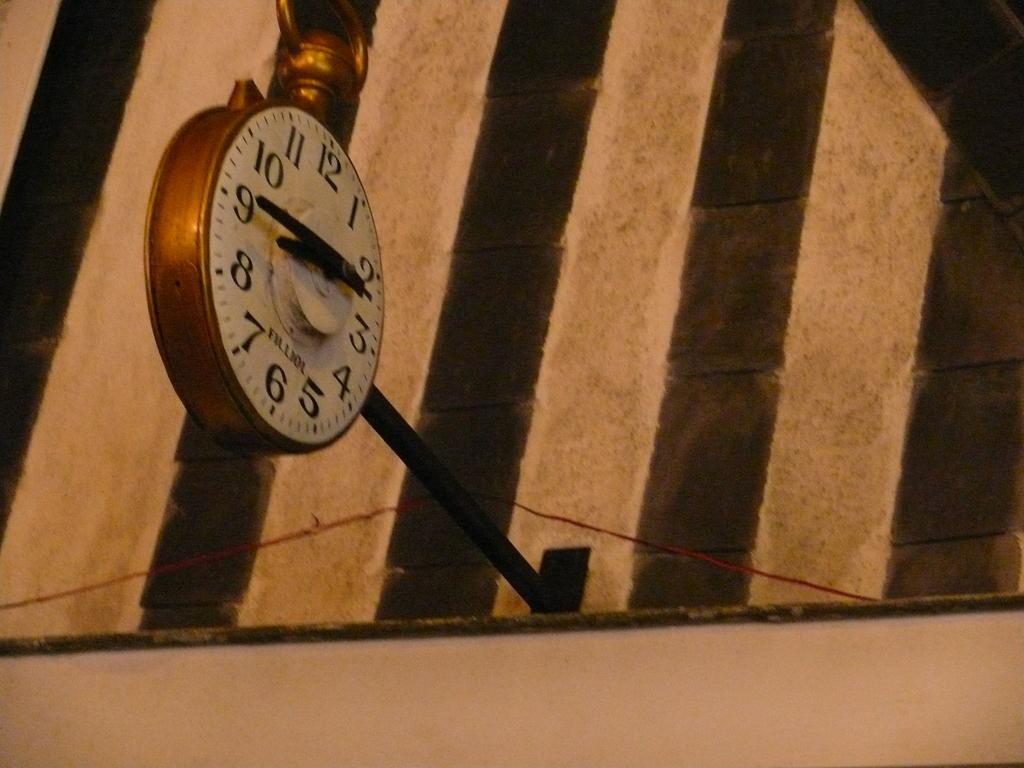Provide a one-sentence caption for the provided image. The large clock is a replica of a pocket watch and the time reads 8:45. 